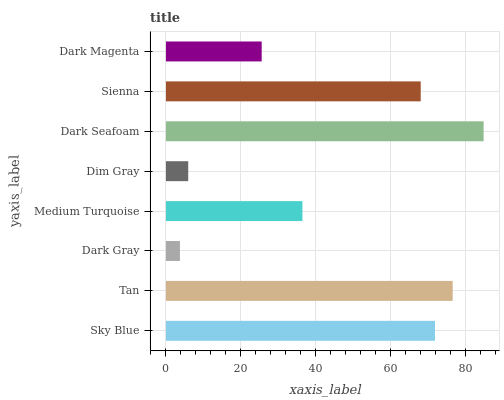Is Dark Gray the minimum?
Answer yes or no. Yes. Is Dark Seafoam the maximum?
Answer yes or no. Yes. Is Tan the minimum?
Answer yes or no. No. Is Tan the maximum?
Answer yes or no. No. Is Tan greater than Sky Blue?
Answer yes or no. Yes. Is Sky Blue less than Tan?
Answer yes or no. Yes. Is Sky Blue greater than Tan?
Answer yes or no. No. Is Tan less than Sky Blue?
Answer yes or no. No. Is Sienna the high median?
Answer yes or no. Yes. Is Medium Turquoise the low median?
Answer yes or no. Yes. Is Sky Blue the high median?
Answer yes or no. No. Is Sienna the low median?
Answer yes or no. No. 